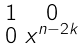<formula> <loc_0><loc_0><loc_500><loc_500>\begin{smallmatrix} 1 & 0 \\ 0 & x ^ { n - 2 k } \end{smallmatrix}</formula> 